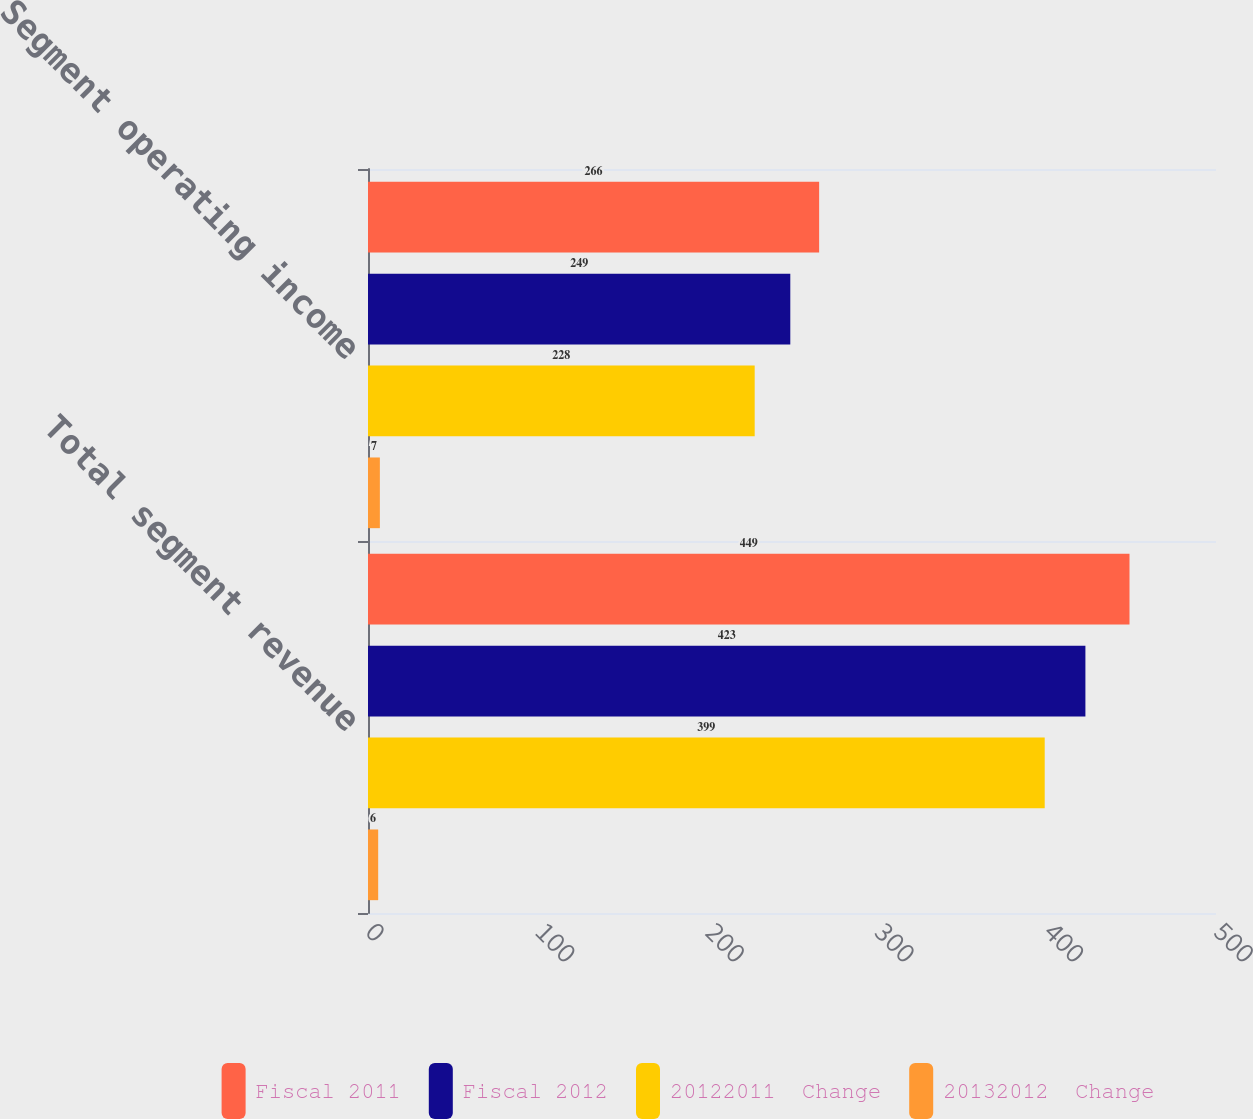Convert chart. <chart><loc_0><loc_0><loc_500><loc_500><stacked_bar_chart><ecel><fcel>Total segment revenue<fcel>Segment operating income<nl><fcel>Fiscal 2011<fcel>449<fcel>266<nl><fcel>Fiscal 2012<fcel>423<fcel>249<nl><fcel>20122011  Change<fcel>399<fcel>228<nl><fcel>20132012  Change<fcel>6<fcel>7<nl></chart> 